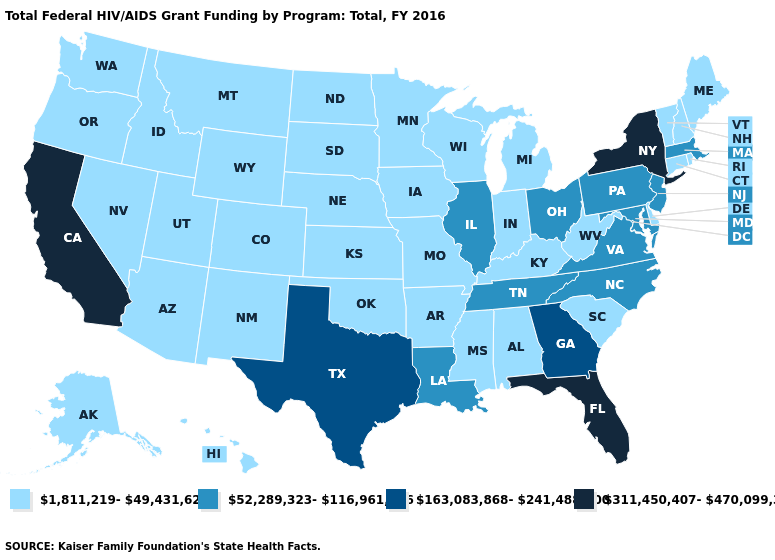Name the states that have a value in the range 311,450,407-470,099,389?
Keep it brief. California, Florida, New York. What is the highest value in the MidWest ?
Keep it brief. 52,289,323-116,961,696. Among the states that border California , which have the highest value?
Keep it brief. Arizona, Nevada, Oregon. Which states have the highest value in the USA?
Write a very short answer. California, Florida, New York. Name the states that have a value in the range 311,450,407-470,099,389?
Short answer required. California, Florida, New York. Does the map have missing data?
Quick response, please. No. Does Missouri have a lower value than Georgia?
Concise answer only. Yes. What is the value of Pennsylvania?
Concise answer only. 52,289,323-116,961,696. Is the legend a continuous bar?
Answer briefly. No. How many symbols are there in the legend?
Give a very brief answer. 4. Name the states that have a value in the range 1,811,219-49,431,623?
Give a very brief answer. Alabama, Alaska, Arizona, Arkansas, Colorado, Connecticut, Delaware, Hawaii, Idaho, Indiana, Iowa, Kansas, Kentucky, Maine, Michigan, Minnesota, Mississippi, Missouri, Montana, Nebraska, Nevada, New Hampshire, New Mexico, North Dakota, Oklahoma, Oregon, Rhode Island, South Carolina, South Dakota, Utah, Vermont, Washington, West Virginia, Wisconsin, Wyoming. What is the lowest value in the USA?
Concise answer only. 1,811,219-49,431,623. Which states have the highest value in the USA?
Be succinct. California, Florida, New York. What is the value of Georgia?
Answer briefly. 163,083,868-241,488,800. Does Vermont have a higher value than Rhode Island?
Keep it brief. No. 